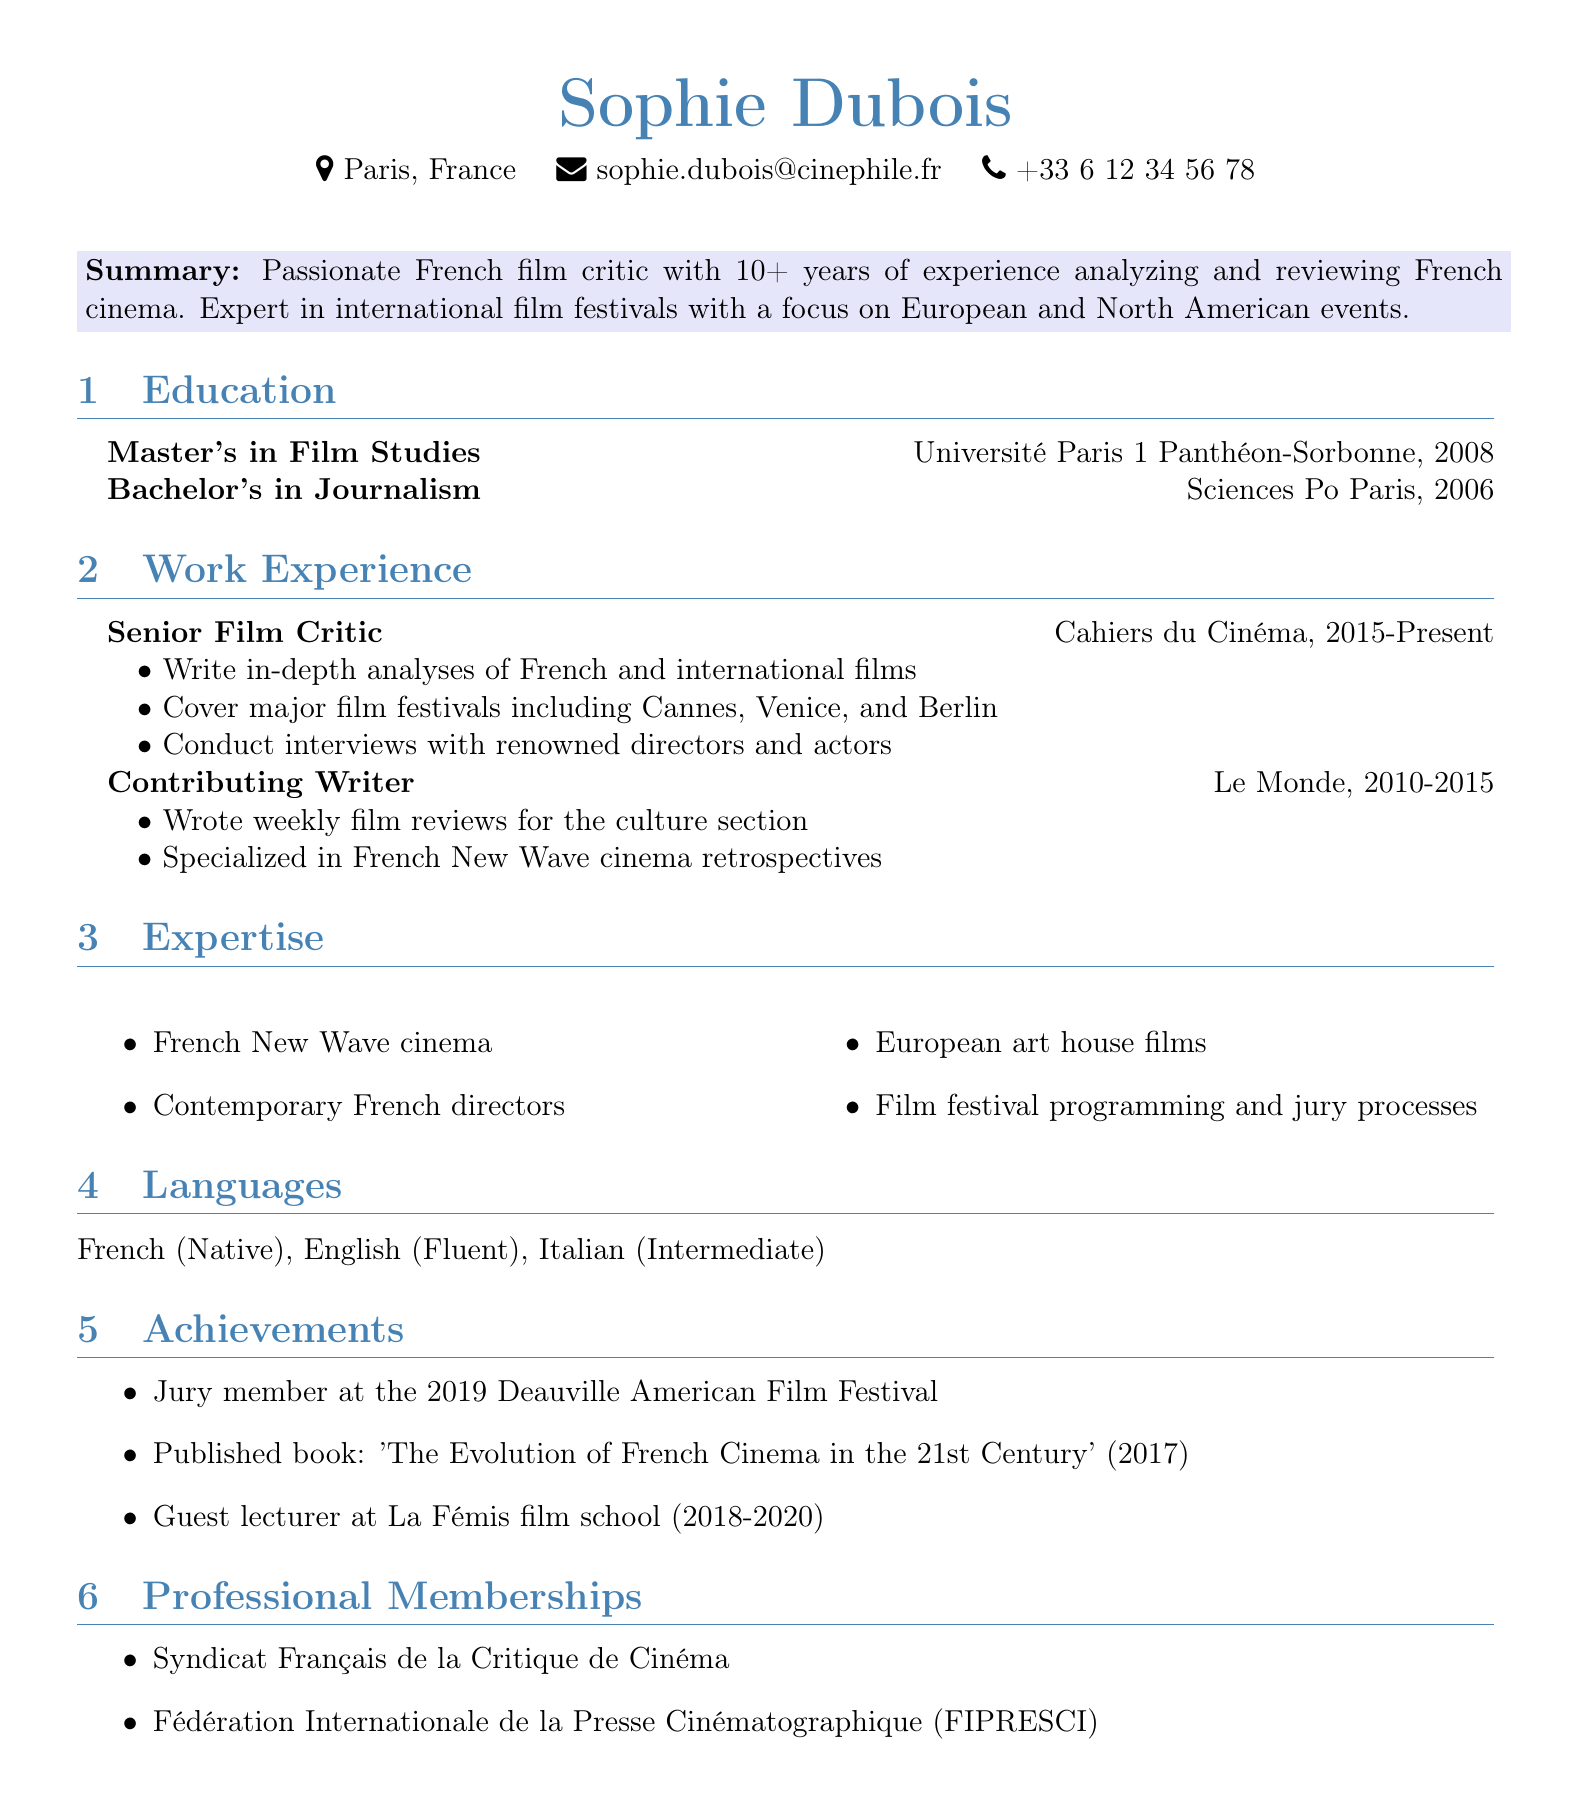What is the name of the film critic? The name of the film critic is provided in the personal info section of the document.
Answer: Sophie Dubois Which city is Sophie Dubois located in? The location is mentioned in the personal info section.
Answer: Paris, France What degree did she earn in 2008? The education section lists her degrees along with the years they were obtained.
Answer: Master's in Film Studies What is one expertise mentioned in the CV? The expertise section lists several areas of expertise related to film.
Answer: French New Wave cinema How many years of experience does Sophie Dubois have? The summary outlines the number of years of experience.
Answer: 10+ At which film festival was she a jury member? The achievements section states her jury member role in a specific film festival.
Answer: Deauville American Film Festival Which publication did she contribute to from 2010 to 2015? The work experience section lists her positions and the companies associated with them during the specified years.
Answer: Le Monde What was the title of her published book? The achievements section includes the title of the book she published.
Answer: The Evolution of French Cinema in the 21st Century What languages does Sophie Dubois speak? The languages section lists the languages she is proficient in.
Answer: French, English, Italian 